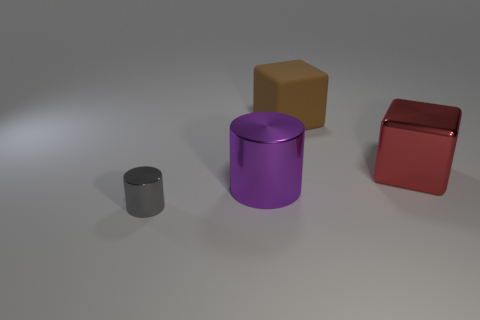Add 1 small cylinders. How many objects exist? 5 Subtract 0 purple spheres. How many objects are left? 4 Subtract all small brown shiny things. Subtract all big rubber things. How many objects are left? 3 Add 4 large red shiny blocks. How many large red shiny blocks are left? 5 Add 4 shiny blocks. How many shiny blocks exist? 5 